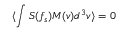<formula> <loc_0><loc_0><loc_500><loc_500>\langle \int S ( f _ { s } ) M ( v ) d ^ { 3 } v \rangle = 0</formula> 